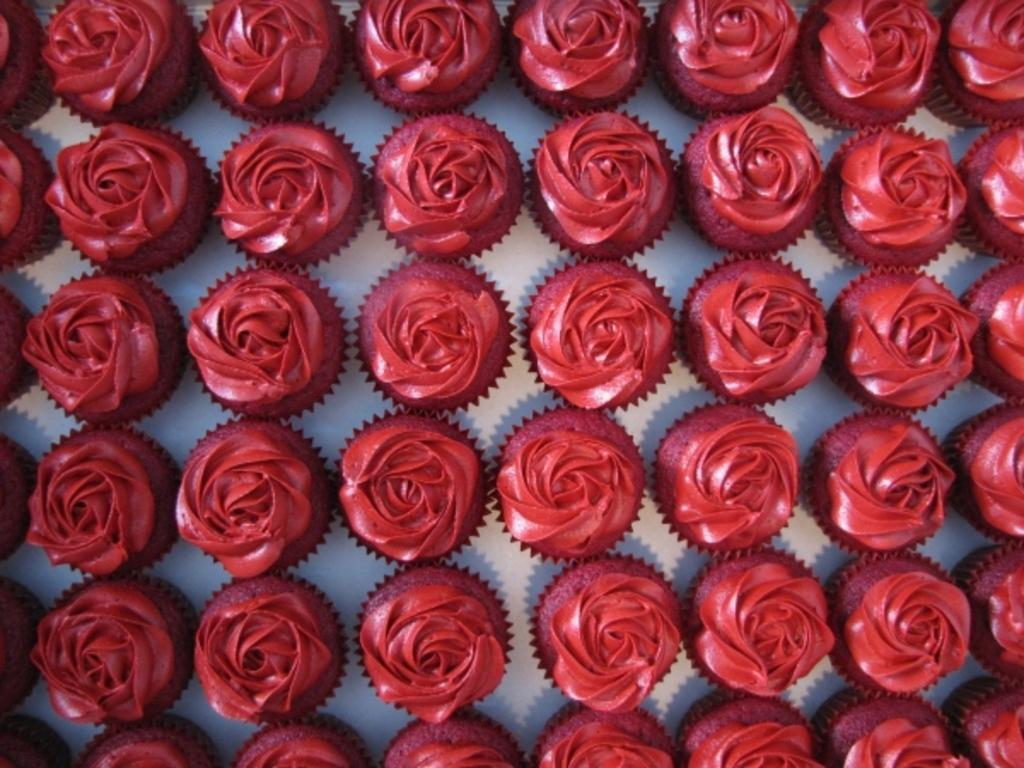What type of dessert can be seen in the image? There are cupcakes in the image. What is on top of the cupcakes? The cupcakes have cream on them. Can you see a kitty kicking the cupcakes in the image? No, there is no kitty or kicking action present in the image. 